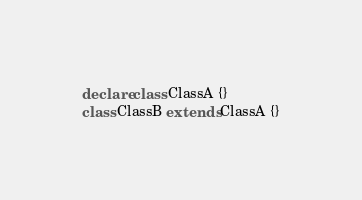Convert code to text. <code><loc_0><loc_0><loc_500><loc_500><_TypeScript_>declare class ClassA {}
class ClassB extends ClassA {}</code> 